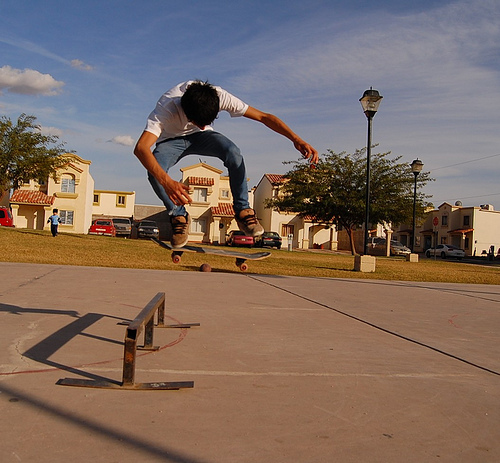Can you describe the setting of this image? The image captures a sunny outdoor setting in a neighborhood with houses in the background. There is an open space with a sidewalk and a metal rail setup likely used for skating tricks. Does this location seem good for skateboarding? The open space, smooth pavement, and presence of the metal rail suggest it's a popular spot for skateboarding activities, allowing for tricks and maneuvers to be performed. 